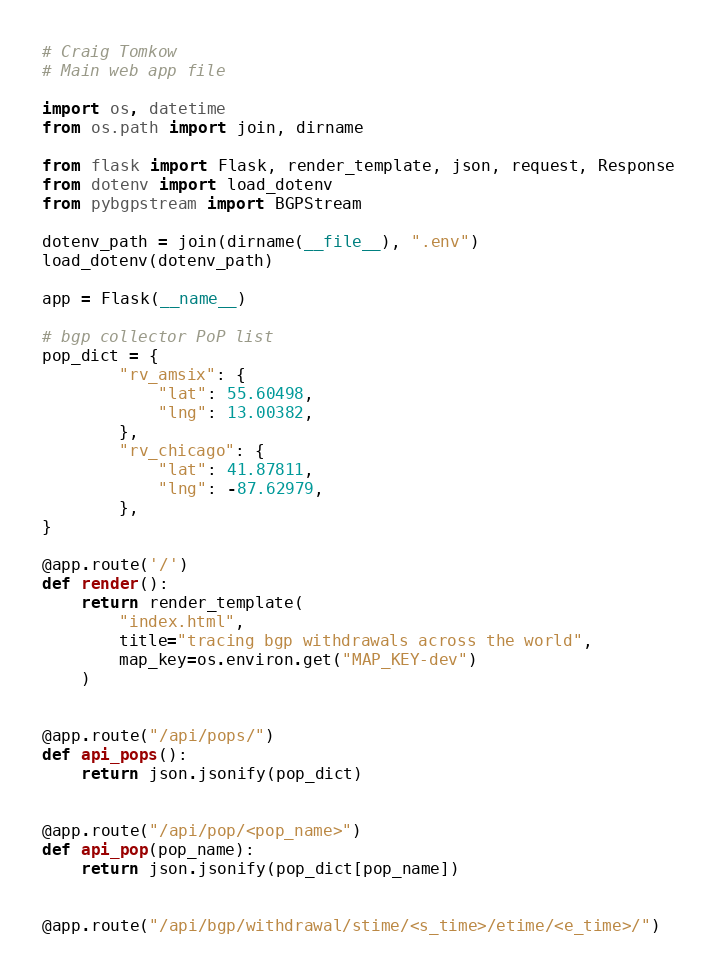Convert code to text. <code><loc_0><loc_0><loc_500><loc_500><_Python_># Craig Tomkow
# Main web app file

import os, datetime
from os.path import join, dirname

from flask import Flask, render_template, json, request, Response
from dotenv import load_dotenv
from pybgpstream import BGPStream

dotenv_path = join(dirname(__file__), ".env")
load_dotenv(dotenv_path)

app = Flask(__name__)

# bgp collector PoP list
pop_dict = {
        "rv_amsix": {
            "lat": 55.60498,
            "lng": 13.00382,
        },
        "rv_chicago": {
            "lat": 41.87811,
            "lng": -87.62979,
        },
}

@app.route('/')
def render():
    return render_template(
        "index.html",
        title="tracing bgp withdrawals across the world",
        map_key=os.environ.get("MAP_KEY-dev")
    )


@app.route("/api/pops/")
def api_pops():
    return json.jsonify(pop_dict)


@app.route("/api/pop/<pop_name>")
def api_pop(pop_name):
    return json.jsonify(pop_dict[pop_name])


@app.route("/api/bgp/withdrawal/stime/<s_time>/etime/<e_time>/")</code> 